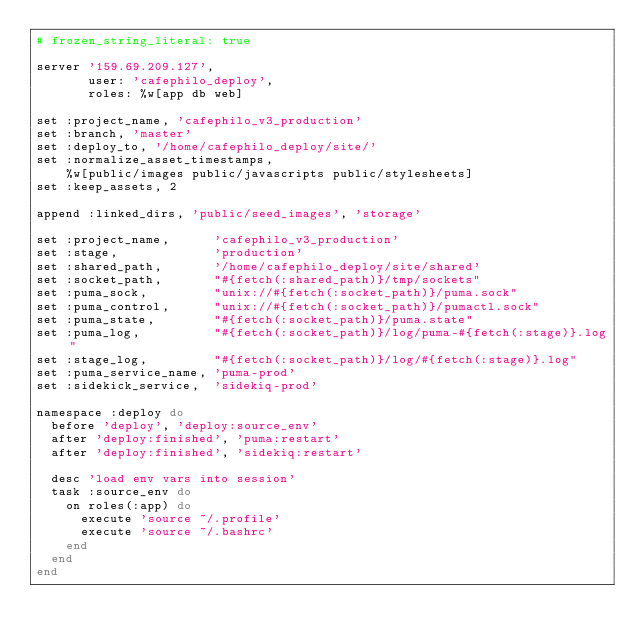Convert code to text. <code><loc_0><loc_0><loc_500><loc_500><_Ruby_># frozen_string_literal: true

server '159.69.209.127',
       user: 'cafephilo_deploy',
       roles: %w[app db web]

set :project_name, 'cafephilo_v3_production'
set :branch, 'master'
set :deploy_to, '/home/cafephilo_deploy/site/'
set :normalize_asset_timestamps,
    %w[public/images public/javascripts public/stylesheets]
set :keep_assets, 2

append :linked_dirs, 'public/seed_images', 'storage'

set :project_name,      'cafephilo_v3_production'
set :stage,             'production'
set :shared_path,       '/home/cafephilo_deploy/site/shared'
set :socket_path,       "#{fetch(:shared_path)}/tmp/sockets"
set :puma_sock,         "unix://#{fetch(:socket_path)}/puma.sock"
set :puma_control,      "unix://#{fetch(:socket_path)}/pumactl.sock"
set :puma_state,        "#{fetch(:socket_path)}/puma.state"
set :puma_log,          "#{fetch(:socket_path)}/log/puma-#{fetch(:stage)}.log"
set :stage_log,         "#{fetch(:socket_path)}/log/#{fetch(:stage)}.log"
set :puma_service_name, 'puma-prod'
set :sidekick_service,  'sidekiq-prod'

namespace :deploy do
  before 'deploy', 'deploy:source_env'
  after 'deploy:finished', 'puma:restart'
  after 'deploy:finished', 'sidekiq:restart'

  desc 'load env vars into session'
  task :source_env do
    on roles(:app) do
      execute 'source ~/.profile'
      execute 'source ~/.bashrc'
    end
  end
end
</code> 